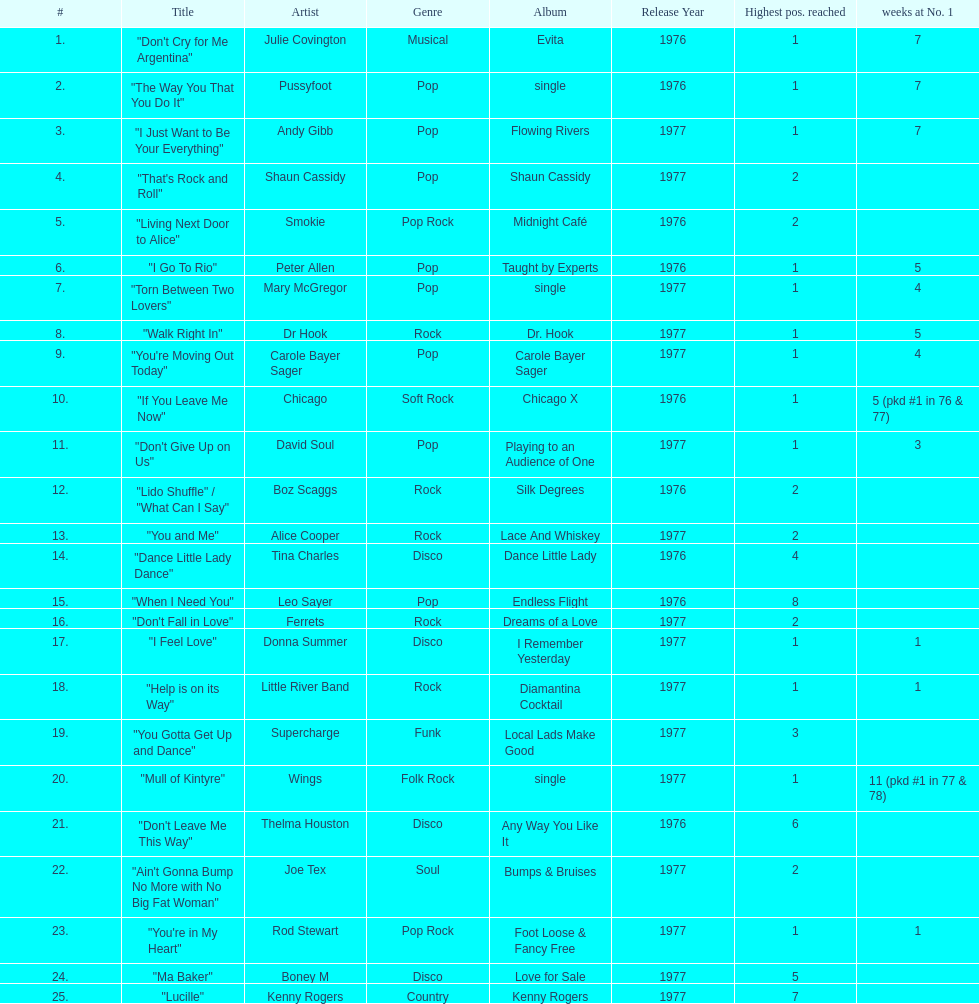Which three artists had a single at number 1 for at least 7 weeks on the australian singles charts in 1977? Julie Covington, Pussyfoot, Andy Gibb. 